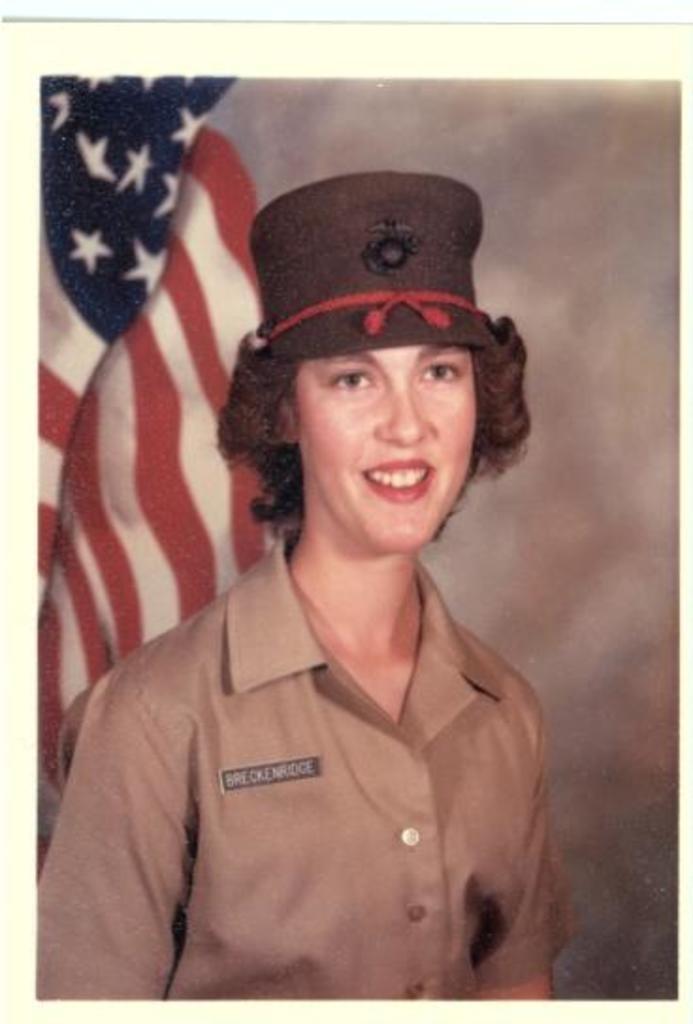Describe this image in one or two sentences. In this image there is a photo, in that photo there is a lady wearing a hat, in the background there is a flag. 